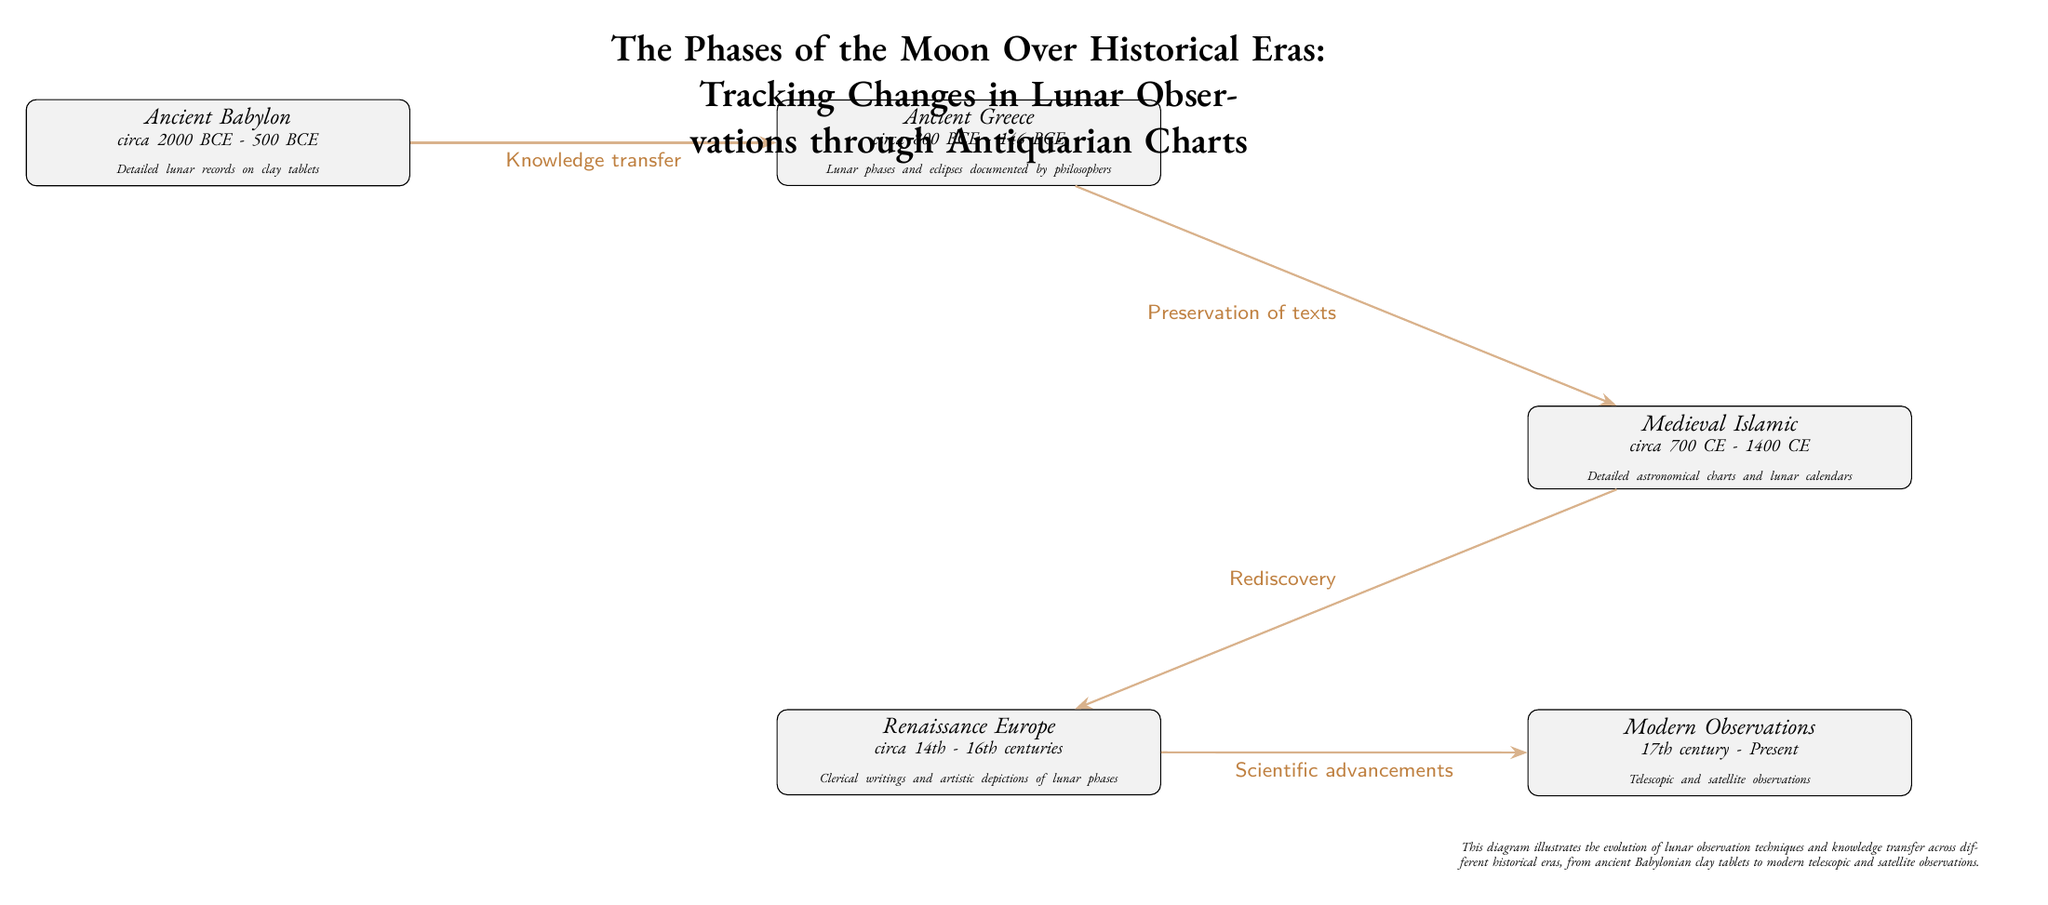What era is associated with detailed lunar records on clay tablets? The diagram shows that Ancient Babylon, circa 2000 BCE - 500 BCE, is the era associated with detailed lunar records on clay tablets.
Answer: Ancient Babylon Which historical era followed Ancient Greece in the diagram? The diagram illustrates that the Medieval Islamic era, circa 700 CE - 1400 CE, followed Ancient Greece, circa 800 BCE - 146 BCE.
Answer: Medieval Islamic What type of knowledge transfer is indicated between Babylon and Greece? The diagram specifies that the knowledge transfer from Babylon to Greece is labelled as "Knowledge transfer," which can be found on the connecting line between the two eras.
Answer: Knowledge transfer How many major historical eras are depicted in the diagram? The diagram clearly lists five distinct eras: Ancient Babylon, Ancient Greece, Medieval Islamic, Renaissance Europe, and Modern Observations, which totals to five major historical eras.
Answer: 5 What notable aspect is highlighted for the Renaissance Europe era? The diagram mentions "Clerical writings and artistic depictions of lunar phases" as the notable aspect for the Renaissance Europe era, emphasizing its contributions to lunar observations.
Answer: Clerical writings and artistic depictions of lunar phases Which era is noted for the use of telescopic and satellite observations? The diagram shows that the Modern Observations era, which spans the 17th century to the present, is noted for utilizing telescopic and satellite observations.
Answer: Modern Observations What is the connecting theme between Islamic and Renaissance Europe eras? The diagram illustrates the connecting theme between these two eras as "Rediscovery," indicating how the knowledge from the Islamic era was rediscovered during the Renaissance.
Answer: Rediscovery What is the time frame for Ancient Greece? Ancient Greece is represented in the diagram as spanning from circa 800 BCE to 146 BCE. This is shown in the node description.
Answer: circa 800 BCE - 146 BCE What visual feature connects each of the eras in the diagram? The diagram uses arrows, specifically represented as "-Stealth" connections, to visually connect each historical era, indicating the flow of knowledge through time.
Answer: Arrows 